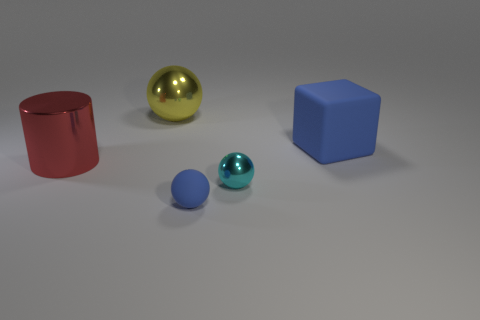Add 4 yellow metallic balls. How many objects exist? 9 Subtract all cylinders. How many objects are left? 4 Add 4 large blue objects. How many large blue objects exist? 5 Subtract 0 purple cubes. How many objects are left? 5 Subtract all blue cylinders. Subtract all large red cylinders. How many objects are left? 4 Add 4 shiny objects. How many shiny objects are left? 7 